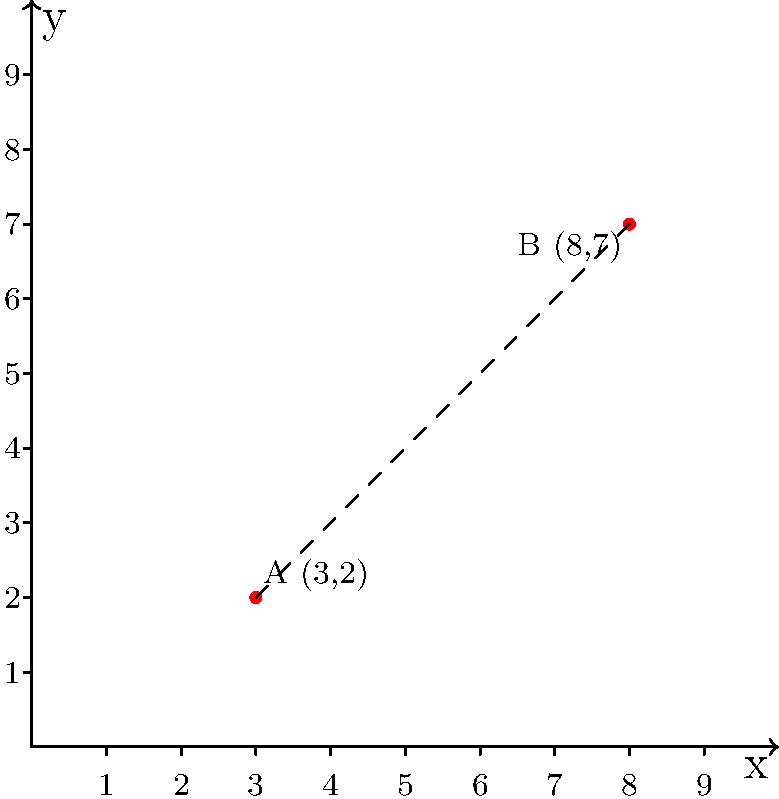On Christmas Island, two landmarks A and B are located at coordinates (3,2) and (8,7) respectively on a local map. Calculate the straight-line distance between these two landmarks using the Cartesian coordinate system. Round your answer to two decimal places. To find the distance between two points in a Cartesian coordinate system, we can use the distance formula, which is derived from the Pythagorean theorem:

$$d = \sqrt{(x_2-x_1)^2 + (y_2-y_1)^2}$$

Where $(x_1,y_1)$ are the coordinates of the first point and $(x_2,y_2)$ are the coordinates of the second point.

Given:
- Point A: $(x_1,y_1) = (3,2)$
- Point B: $(x_2,y_2) = (8,7)$

Let's substitute these values into the formula:

$$\begin{align}
d &= \sqrt{(8-3)^2 + (7-2)^2} \\
&= \sqrt{5^2 + 5^2} \\
&= \sqrt{25 + 25} \\
&= \sqrt{50} \\
&= 5\sqrt{2} \\
&\approx 7.07
\end{align}$$

Rounding to two decimal places, we get 7.07.
Answer: 7.07 units 